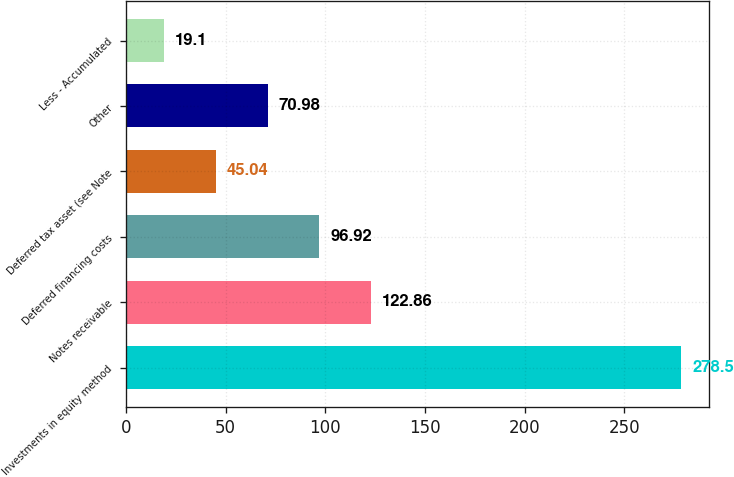Convert chart. <chart><loc_0><loc_0><loc_500><loc_500><bar_chart><fcel>Investments in equity method<fcel>Notes receivable<fcel>Deferred financing costs<fcel>Deferred tax asset (see Note<fcel>Other<fcel>Less - Accumulated<nl><fcel>278.5<fcel>122.86<fcel>96.92<fcel>45.04<fcel>70.98<fcel>19.1<nl></chart> 